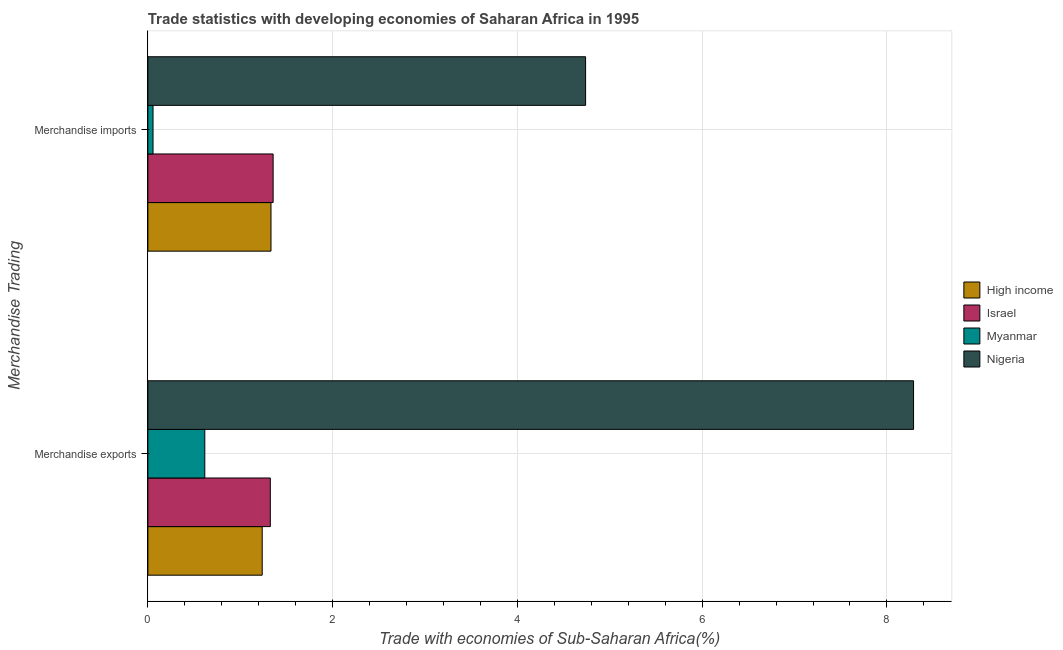Are the number of bars per tick equal to the number of legend labels?
Provide a succinct answer. Yes. How many bars are there on the 2nd tick from the top?
Your answer should be compact. 4. What is the label of the 2nd group of bars from the top?
Your answer should be compact. Merchandise exports. What is the merchandise imports in High income?
Provide a succinct answer. 1.33. Across all countries, what is the maximum merchandise imports?
Keep it short and to the point. 4.74. Across all countries, what is the minimum merchandise imports?
Your response must be concise. 0.06. In which country was the merchandise exports maximum?
Ensure brevity in your answer.  Nigeria. In which country was the merchandise imports minimum?
Your response must be concise. Myanmar. What is the total merchandise exports in the graph?
Your response must be concise. 11.47. What is the difference between the merchandise imports in High income and that in Nigeria?
Your response must be concise. -3.41. What is the difference between the merchandise imports in Myanmar and the merchandise exports in High income?
Provide a succinct answer. -1.18. What is the average merchandise imports per country?
Offer a very short reply. 1.87. What is the difference between the merchandise exports and merchandise imports in High income?
Your response must be concise. -0.1. What is the ratio of the merchandise exports in High income to that in Myanmar?
Your response must be concise. 2.01. Is the merchandise imports in Myanmar less than that in Israel?
Ensure brevity in your answer.  Yes. What does the 2nd bar from the bottom in Merchandise imports represents?
Make the answer very short. Israel. How many countries are there in the graph?
Make the answer very short. 4. What is the difference between two consecutive major ticks on the X-axis?
Offer a terse response. 2. Does the graph contain grids?
Provide a short and direct response. Yes. What is the title of the graph?
Your response must be concise. Trade statistics with developing economies of Saharan Africa in 1995. Does "Peru" appear as one of the legend labels in the graph?
Keep it short and to the point. No. What is the label or title of the X-axis?
Offer a very short reply. Trade with economies of Sub-Saharan Africa(%). What is the label or title of the Y-axis?
Your answer should be very brief. Merchandise Trading. What is the Trade with economies of Sub-Saharan Africa(%) of High income in Merchandise exports?
Your answer should be compact. 1.24. What is the Trade with economies of Sub-Saharan Africa(%) in Israel in Merchandise exports?
Provide a short and direct response. 1.33. What is the Trade with economies of Sub-Saharan Africa(%) in Myanmar in Merchandise exports?
Make the answer very short. 0.62. What is the Trade with economies of Sub-Saharan Africa(%) of Nigeria in Merchandise exports?
Ensure brevity in your answer.  8.29. What is the Trade with economies of Sub-Saharan Africa(%) of High income in Merchandise imports?
Your answer should be compact. 1.33. What is the Trade with economies of Sub-Saharan Africa(%) in Israel in Merchandise imports?
Your answer should be compact. 1.36. What is the Trade with economies of Sub-Saharan Africa(%) in Myanmar in Merchandise imports?
Offer a terse response. 0.06. What is the Trade with economies of Sub-Saharan Africa(%) of Nigeria in Merchandise imports?
Your answer should be very brief. 4.74. Across all Merchandise Trading, what is the maximum Trade with economies of Sub-Saharan Africa(%) of High income?
Provide a succinct answer. 1.33. Across all Merchandise Trading, what is the maximum Trade with economies of Sub-Saharan Africa(%) in Israel?
Your answer should be compact. 1.36. Across all Merchandise Trading, what is the maximum Trade with economies of Sub-Saharan Africa(%) in Myanmar?
Your answer should be very brief. 0.62. Across all Merchandise Trading, what is the maximum Trade with economies of Sub-Saharan Africa(%) in Nigeria?
Provide a short and direct response. 8.29. Across all Merchandise Trading, what is the minimum Trade with economies of Sub-Saharan Africa(%) in High income?
Your answer should be very brief. 1.24. Across all Merchandise Trading, what is the minimum Trade with economies of Sub-Saharan Africa(%) of Israel?
Give a very brief answer. 1.33. Across all Merchandise Trading, what is the minimum Trade with economies of Sub-Saharan Africa(%) of Myanmar?
Your answer should be compact. 0.06. Across all Merchandise Trading, what is the minimum Trade with economies of Sub-Saharan Africa(%) in Nigeria?
Keep it short and to the point. 4.74. What is the total Trade with economies of Sub-Saharan Africa(%) in High income in the graph?
Make the answer very short. 2.57. What is the total Trade with economies of Sub-Saharan Africa(%) of Israel in the graph?
Your response must be concise. 2.68. What is the total Trade with economies of Sub-Saharan Africa(%) of Myanmar in the graph?
Offer a terse response. 0.67. What is the total Trade with economies of Sub-Saharan Africa(%) of Nigeria in the graph?
Keep it short and to the point. 13.03. What is the difference between the Trade with economies of Sub-Saharan Africa(%) of High income in Merchandise exports and that in Merchandise imports?
Ensure brevity in your answer.  -0.1. What is the difference between the Trade with economies of Sub-Saharan Africa(%) of Israel in Merchandise exports and that in Merchandise imports?
Give a very brief answer. -0.03. What is the difference between the Trade with economies of Sub-Saharan Africa(%) of Myanmar in Merchandise exports and that in Merchandise imports?
Ensure brevity in your answer.  0.56. What is the difference between the Trade with economies of Sub-Saharan Africa(%) in Nigeria in Merchandise exports and that in Merchandise imports?
Provide a succinct answer. 3.55. What is the difference between the Trade with economies of Sub-Saharan Africa(%) in High income in Merchandise exports and the Trade with economies of Sub-Saharan Africa(%) in Israel in Merchandise imports?
Give a very brief answer. -0.12. What is the difference between the Trade with economies of Sub-Saharan Africa(%) in High income in Merchandise exports and the Trade with economies of Sub-Saharan Africa(%) in Myanmar in Merchandise imports?
Provide a succinct answer. 1.18. What is the difference between the Trade with economies of Sub-Saharan Africa(%) in High income in Merchandise exports and the Trade with economies of Sub-Saharan Africa(%) in Nigeria in Merchandise imports?
Offer a very short reply. -3.5. What is the difference between the Trade with economies of Sub-Saharan Africa(%) in Israel in Merchandise exports and the Trade with economies of Sub-Saharan Africa(%) in Myanmar in Merchandise imports?
Provide a succinct answer. 1.27. What is the difference between the Trade with economies of Sub-Saharan Africa(%) of Israel in Merchandise exports and the Trade with economies of Sub-Saharan Africa(%) of Nigeria in Merchandise imports?
Make the answer very short. -3.41. What is the difference between the Trade with economies of Sub-Saharan Africa(%) in Myanmar in Merchandise exports and the Trade with economies of Sub-Saharan Africa(%) in Nigeria in Merchandise imports?
Provide a succinct answer. -4.12. What is the average Trade with economies of Sub-Saharan Africa(%) in High income per Merchandise Trading?
Your response must be concise. 1.29. What is the average Trade with economies of Sub-Saharan Africa(%) in Israel per Merchandise Trading?
Offer a terse response. 1.34. What is the average Trade with economies of Sub-Saharan Africa(%) in Myanmar per Merchandise Trading?
Offer a very short reply. 0.34. What is the average Trade with economies of Sub-Saharan Africa(%) in Nigeria per Merchandise Trading?
Keep it short and to the point. 6.51. What is the difference between the Trade with economies of Sub-Saharan Africa(%) in High income and Trade with economies of Sub-Saharan Africa(%) in Israel in Merchandise exports?
Provide a succinct answer. -0.09. What is the difference between the Trade with economies of Sub-Saharan Africa(%) of High income and Trade with economies of Sub-Saharan Africa(%) of Myanmar in Merchandise exports?
Offer a terse response. 0.62. What is the difference between the Trade with economies of Sub-Saharan Africa(%) in High income and Trade with economies of Sub-Saharan Africa(%) in Nigeria in Merchandise exports?
Provide a short and direct response. -7.05. What is the difference between the Trade with economies of Sub-Saharan Africa(%) of Israel and Trade with economies of Sub-Saharan Africa(%) of Myanmar in Merchandise exports?
Your answer should be very brief. 0.71. What is the difference between the Trade with economies of Sub-Saharan Africa(%) in Israel and Trade with economies of Sub-Saharan Africa(%) in Nigeria in Merchandise exports?
Keep it short and to the point. -6.96. What is the difference between the Trade with economies of Sub-Saharan Africa(%) of Myanmar and Trade with economies of Sub-Saharan Africa(%) of Nigeria in Merchandise exports?
Offer a very short reply. -7.67. What is the difference between the Trade with economies of Sub-Saharan Africa(%) of High income and Trade with economies of Sub-Saharan Africa(%) of Israel in Merchandise imports?
Your answer should be compact. -0.02. What is the difference between the Trade with economies of Sub-Saharan Africa(%) in High income and Trade with economies of Sub-Saharan Africa(%) in Myanmar in Merchandise imports?
Give a very brief answer. 1.28. What is the difference between the Trade with economies of Sub-Saharan Africa(%) of High income and Trade with economies of Sub-Saharan Africa(%) of Nigeria in Merchandise imports?
Offer a very short reply. -3.41. What is the difference between the Trade with economies of Sub-Saharan Africa(%) of Israel and Trade with economies of Sub-Saharan Africa(%) of Myanmar in Merchandise imports?
Make the answer very short. 1.3. What is the difference between the Trade with economies of Sub-Saharan Africa(%) of Israel and Trade with economies of Sub-Saharan Africa(%) of Nigeria in Merchandise imports?
Give a very brief answer. -3.38. What is the difference between the Trade with economies of Sub-Saharan Africa(%) in Myanmar and Trade with economies of Sub-Saharan Africa(%) in Nigeria in Merchandise imports?
Keep it short and to the point. -4.68. What is the ratio of the Trade with economies of Sub-Saharan Africa(%) in High income in Merchandise exports to that in Merchandise imports?
Provide a succinct answer. 0.93. What is the ratio of the Trade with economies of Sub-Saharan Africa(%) of Israel in Merchandise exports to that in Merchandise imports?
Provide a succinct answer. 0.98. What is the ratio of the Trade with economies of Sub-Saharan Africa(%) of Myanmar in Merchandise exports to that in Merchandise imports?
Your response must be concise. 11.02. What is the ratio of the Trade with economies of Sub-Saharan Africa(%) in Nigeria in Merchandise exports to that in Merchandise imports?
Keep it short and to the point. 1.75. What is the difference between the highest and the second highest Trade with economies of Sub-Saharan Africa(%) in High income?
Offer a very short reply. 0.1. What is the difference between the highest and the second highest Trade with economies of Sub-Saharan Africa(%) in Israel?
Keep it short and to the point. 0.03. What is the difference between the highest and the second highest Trade with economies of Sub-Saharan Africa(%) in Myanmar?
Your answer should be compact. 0.56. What is the difference between the highest and the second highest Trade with economies of Sub-Saharan Africa(%) of Nigeria?
Keep it short and to the point. 3.55. What is the difference between the highest and the lowest Trade with economies of Sub-Saharan Africa(%) in High income?
Your response must be concise. 0.1. What is the difference between the highest and the lowest Trade with economies of Sub-Saharan Africa(%) of Israel?
Ensure brevity in your answer.  0.03. What is the difference between the highest and the lowest Trade with economies of Sub-Saharan Africa(%) in Myanmar?
Make the answer very short. 0.56. What is the difference between the highest and the lowest Trade with economies of Sub-Saharan Africa(%) of Nigeria?
Make the answer very short. 3.55. 